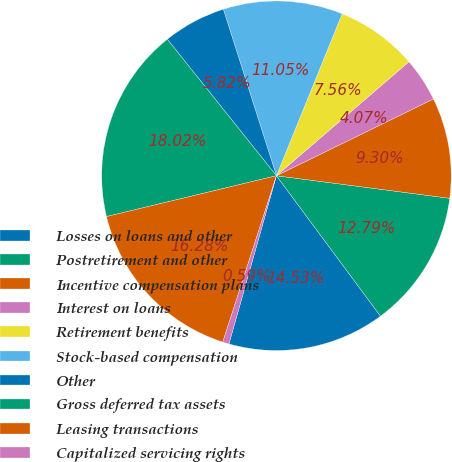Convert chart to OTSL. <chart><loc_0><loc_0><loc_500><loc_500><pie_chart><fcel>Losses on loans and other<fcel>Postretirement and other<fcel>Incentive compensation plans<fcel>Interest on loans<fcel>Retirement benefits<fcel>Stock-based compensation<fcel>Other<fcel>Gross deferred tax assets<fcel>Leasing transactions<fcel>Capitalized servicing rights<nl><fcel>14.53%<fcel>12.79%<fcel>9.3%<fcel>4.07%<fcel>7.56%<fcel>11.05%<fcel>5.82%<fcel>18.02%<fcel>16.28%<fcel>0.59%<nl></chart> 